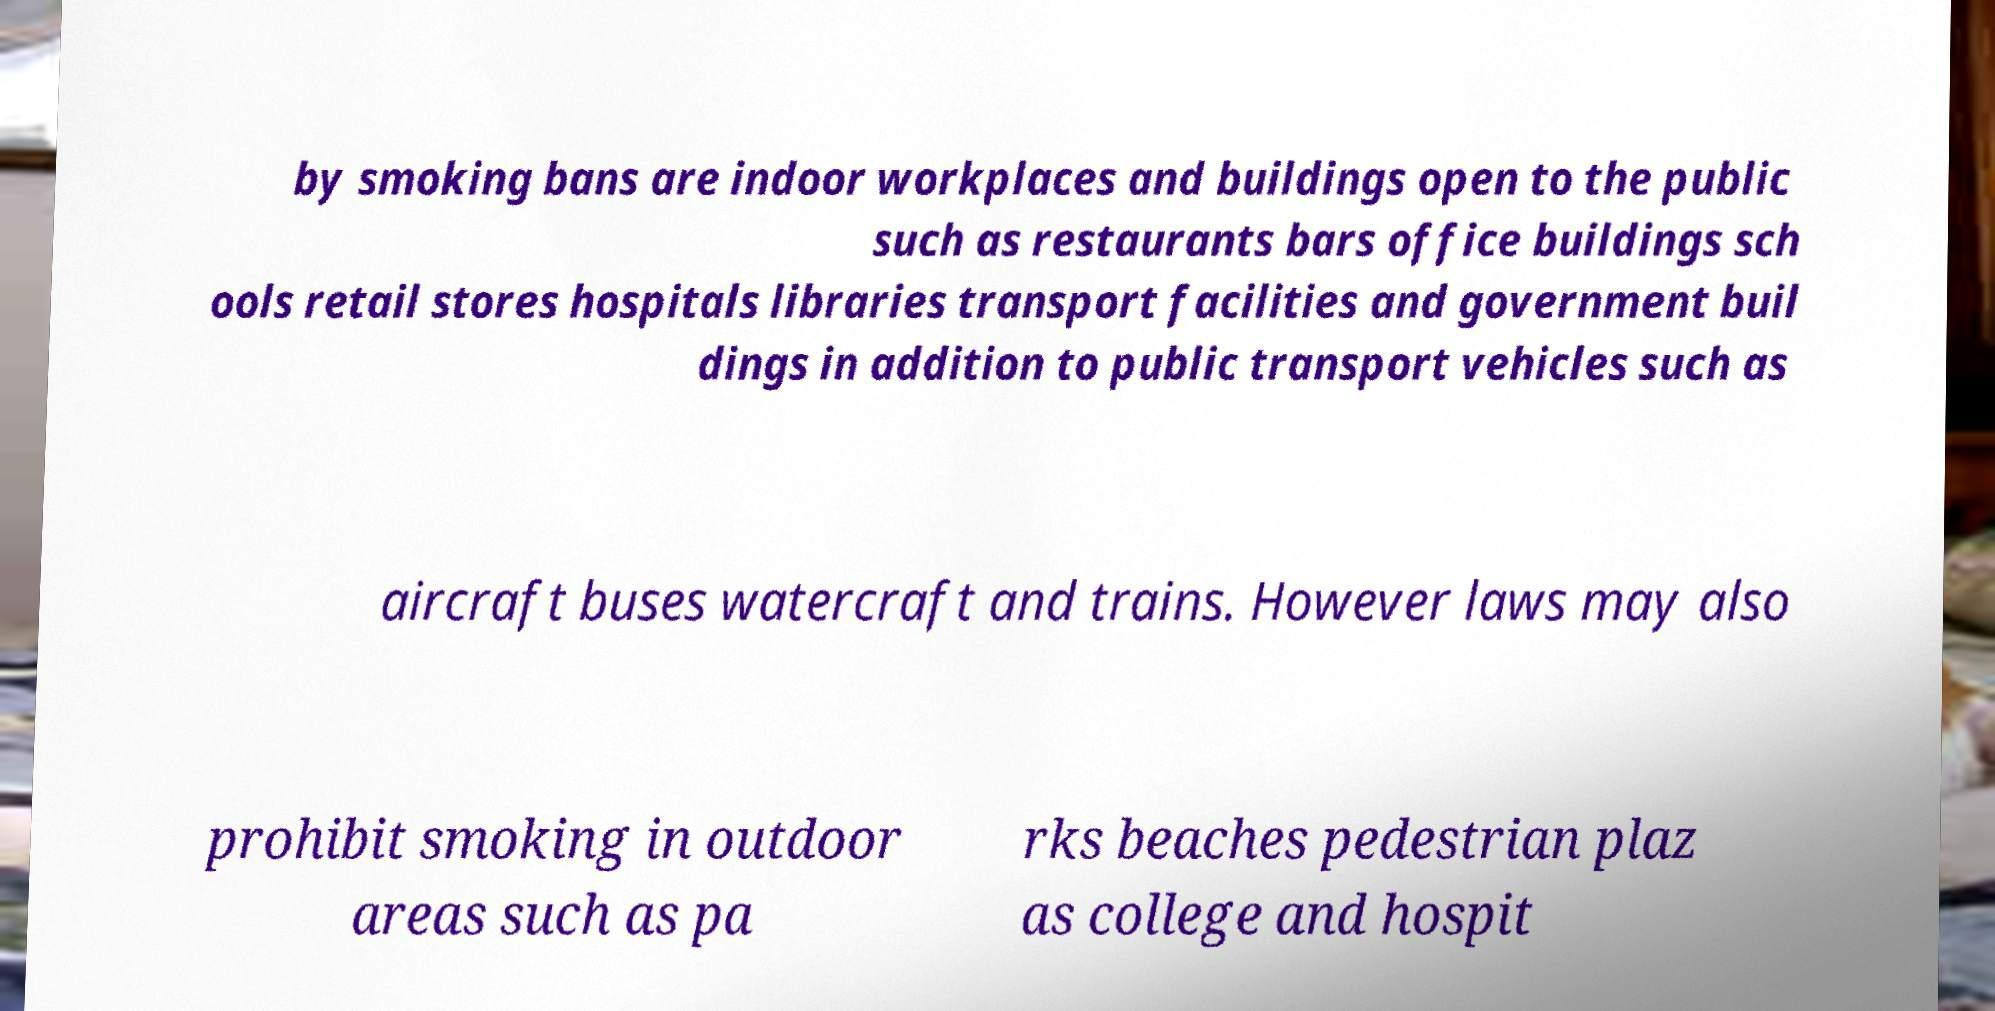There's text embedded in this image that I need extracted. Can you transcribe it verbatim? by smoking bans are indoor workplaces and buildings open to the public such as restaurants bars office buildings sch ools retail stores hospitals libraries transport facilities and government buil dings in addition to public transport vehicles such as aircraft buses watercraft and trains. However laws may also prohibit smoking in outdoor areas such as pa rks beaches pedestrian plaz as college and hospit 